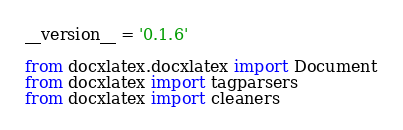<code> <loc_0><loc_0><loc_500><loc_500><_Python_>__version__ = '0.1.6'

from docxlatex.docxlatex import Document
from docxlatex import tagparsers
from docxlatex import cleaners
</code> 